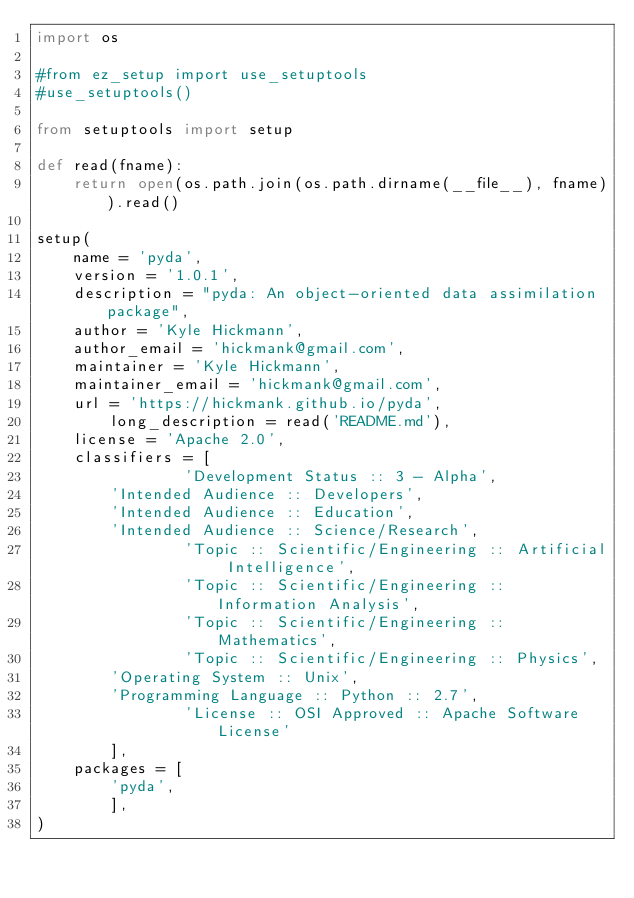<code> <loc_0><loc_0><loc_500><loc_500><_Python_>import os

#from ez_setup import use_setuptools
#use_setuptools()

from setuptools import setup

def read(fname):
    return open(os.path.join(os.path.dirname(__file__), fname)).read()

setup(
	name = 'pyda',
	version = '1.0.1',
	description = "pyda: An object-oriented data assimilation package",
	author = 'Kyle Hickmann',
	author_email = 'hickmank@gmail.com',
	maintainer = 'Kyle Hickmann',
	maintainer_email = 'hickmank@gmail.com',
	url = 'https://hickmank.github.io/pyda',
        long_description = read('README.md'),
	license = 'Apache 2.0',
	classifiers = [
                'Development Status :: 3 - Alpha',
		'Intended Audience :: Developers',
		'Intended Audience :: Education',
		'Intended Audience :: Science/Research',
                'Topic :: Scientific/Engineering :: Artificial Intelligence',
                'Topic :: Scientific/Engineering :: Information Analysis',
                'Topic :: Scientific/Engineering :: Mathematics',
                'Topic :: Scientific/Engineering :: Physics',
		'Operating System :: Unix',
		'Programming Language :: Python :: 2.7',
                'License :: OSI Approved :: Apache Software License'
		],
	packages = [
		'pyda',
		],
)
</code> 